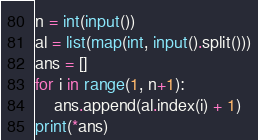Convert code to text. <code><loc_0><loc_0><loc_500><loc_500><_Python_>n = int(input())
al = list(map(int, input().split()))
ans = []
for i in range(1, n+1):
    ans.append(al.index(i) + 1)
print(*ans)</code> 